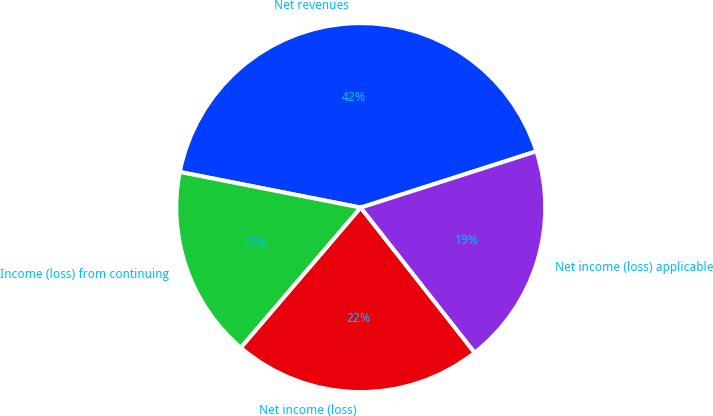<chart> <loc_0><loc_0><loc_500><loc_500><pie_chart><fcel>Net revenues<fcel>Income (loss) from continuing<fcel>Net income (loss)<fcel>Net income (loss) applicable<nl><fcel>41.97%<fcel>16.83%<fcel>21.86%<fcel>19.34%<nl></chart> 